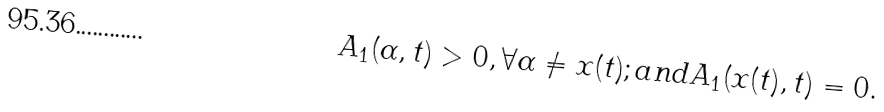Convert formula to latex. <formula><loc_0><loc_0><loc_500><loc_500>A _ { 1 } ( \alpha , t ) > 0 , \forall \alpha \neq x ( t ) ; a n d A _ { 1 } ( x ( t ) , t ) = 0 .</formula> 